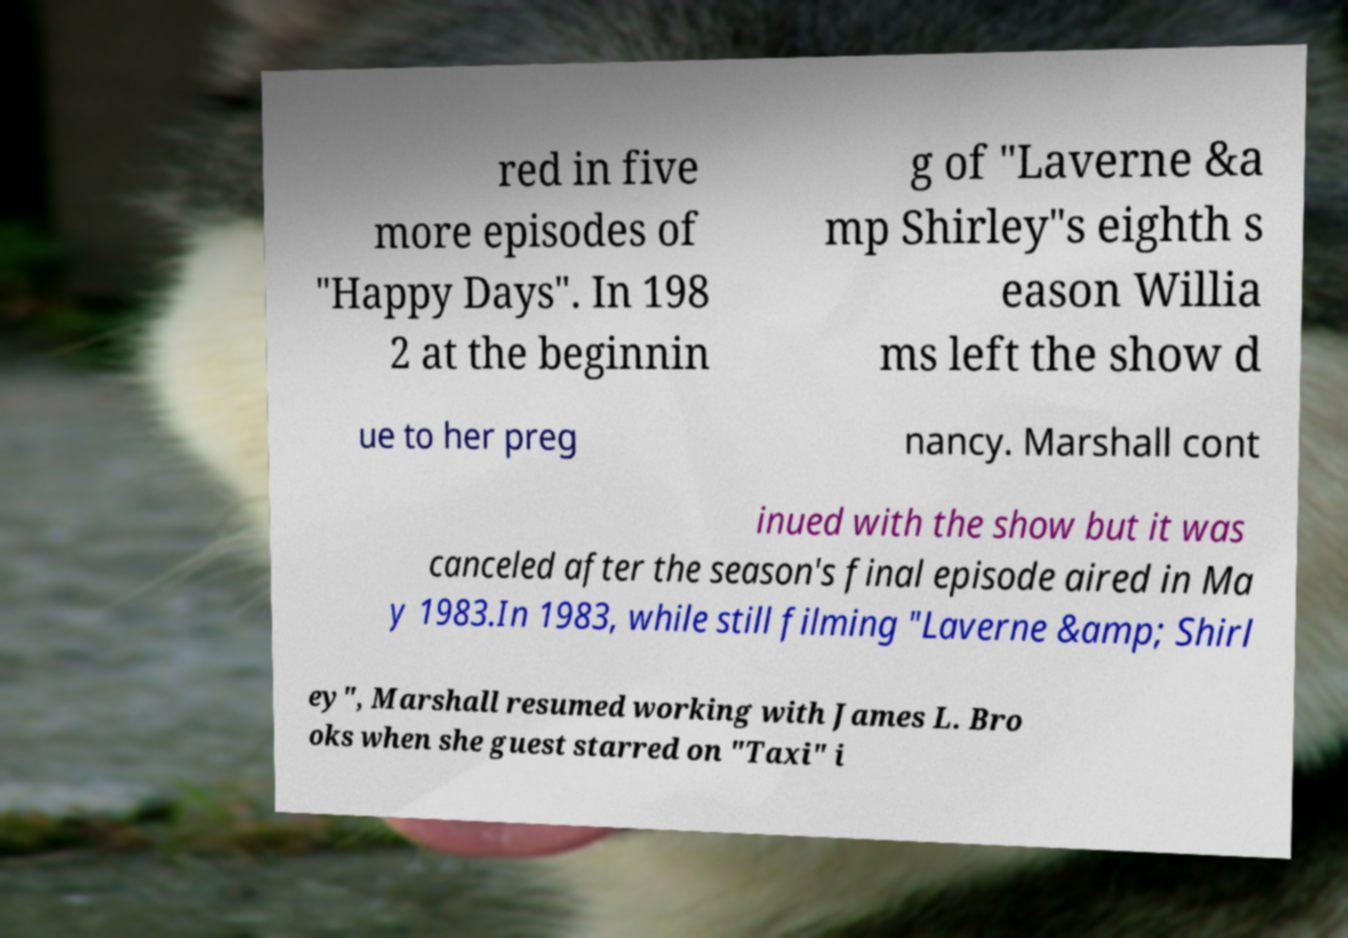For documentation purposes, I need the text within this image transcribed. Could you provide that? red in five more episodes of "Happy Days". In 198 2 at the beginnin g of "Laverne &a mp Shirley"s eighth s eason Willia ms left the show d ue to her preg nancy. Marshall cont inued with the show but it was canceled after the season's final episode aired in Ma y 1983.In 1983, while still filming "Laverne &amp; Shirl ey", Marshall resumed working with James L. Bro oks when she guest starred on "Taxi" i 